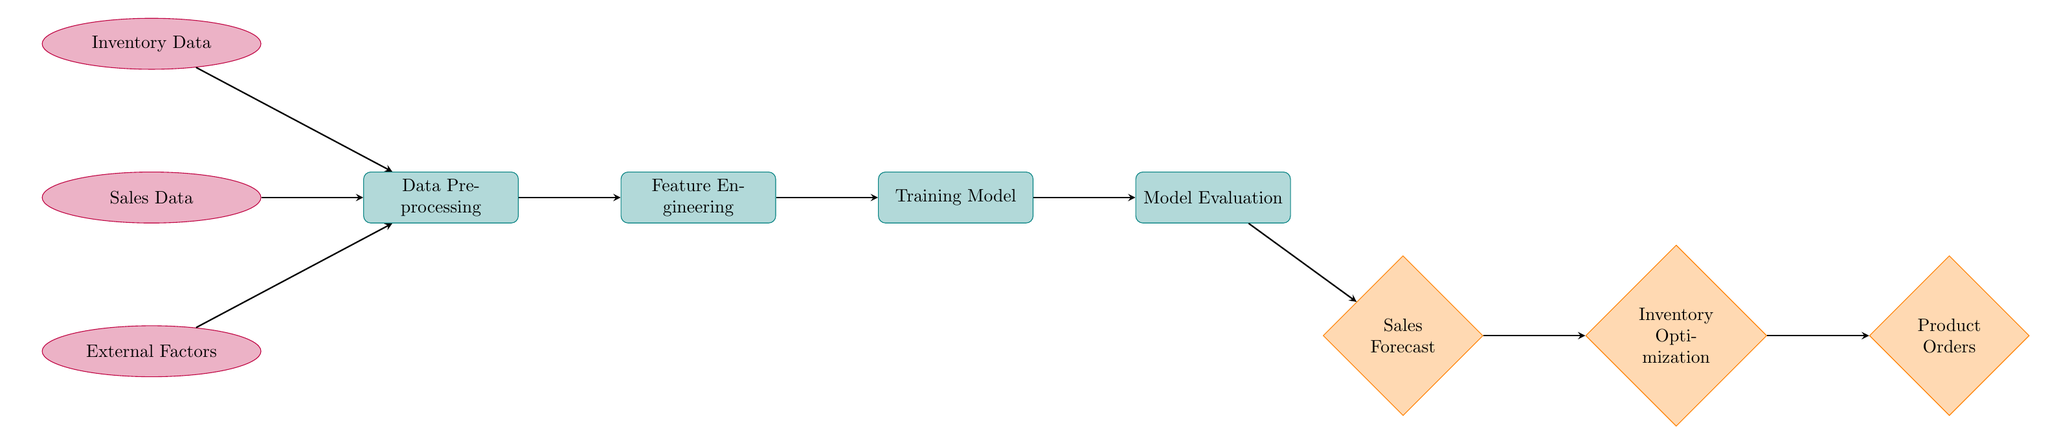What is the first data input in the diagram? The diagram shows "Inventory Data" as the first data input node, which is at the top of the flow.
Answer: Inventory Data How many process nodes are in the diagram? By counting the shapes that represent processes, there are four process nodes: Data Preprocessing, Feature Engineering, Training Model, and Model Evaluation.
Answer: 4 Which node follows Sales Data? Following Sales Data in the diagram is the "Data Preprocessing" node, which receives this data as input.
Answer: Data Preprocessing What type of node is 'Sales Forecast'? The 'Sales Forecast' node is represented as a diamond shape in the diagram, indicating it is an output node.
Answer: Output What inputs contribute to the data preprocessing step? The inputs that contribute to the Data Preprocessing step include Inventory Data, Sales Data, and External Factors, as indicated by the arrows leading into it.
Answer: Inventory Data, Sales Data, External Factors What is the final output of the diagram? The final output of the diagram is labeled as "Product Orders," which comes after the inventory optimization step in the flow.
Answer: Product Orders Which process comes before Model Evaluation? The process that comes immediately before Model Evaluation is "Training Model," as reflected in the flow of the diagram.
Answer: Training Model What type of diagram is this? This diagram represents a Machine Learning process, focusing on inventory management and sales forecasting for hair products and supplies.
Answer: Machine Learning Diagram 